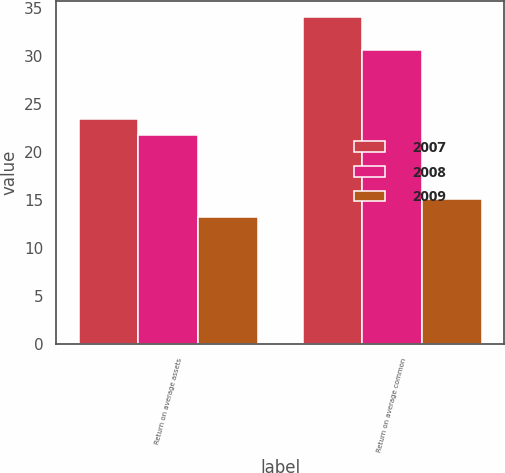<chart> <loc_0><loc_0><loc_500><loc_500><stacked_bar_chart><ecel><fcel>Return on average assets<fcel>Return on average common<nl><fcel>2007<fcel>23.4<fcel>34<nl><fcel>2008<fcel>21.8<fcel>30.6<nl><fcel>2009<fcel>13.2<fcel>15.1<nl></chart> 